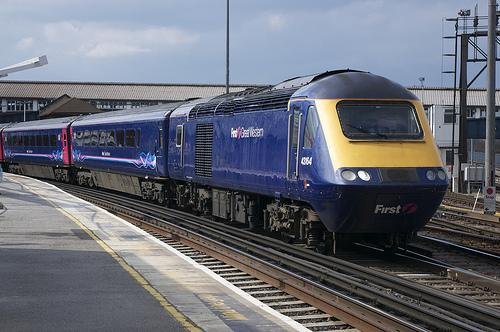Mention any notable nearby structures or objects around the train. There is a train platform with a yellow line and a building nearby. Identify an object that indicates the direction of the train travel and describe it. The yellow front of the train signals its direction of travel. What do the white lights on the train represent, and where are they located? The white lights are headlights, located on the left and right side of the front of the train. What elements of the image suggest it is daytime or nighttime? The image shows a daytime scene, as there are no visible shadows or artificial light sources. What is the condition of the train tracks and what are they made of? The train tracks have rust and are made of steel. Describe the train's front window and conductor's location. The front window of the train is rectangular, and the conductor is located nearby. Count the number of train cars and describe their color. There are three blue train cars with gray roofs. Give a brief description of the train tracks and the platform. The train tracks are steel with rust, and the platform has a yellow line painted on it. What type of vehicle is the primary focus in the image? A blue train with yellow front and white lettering. Describe any visible text on the train and mention its location. "First" is written in white lettering on a blue background on the side of the train. 